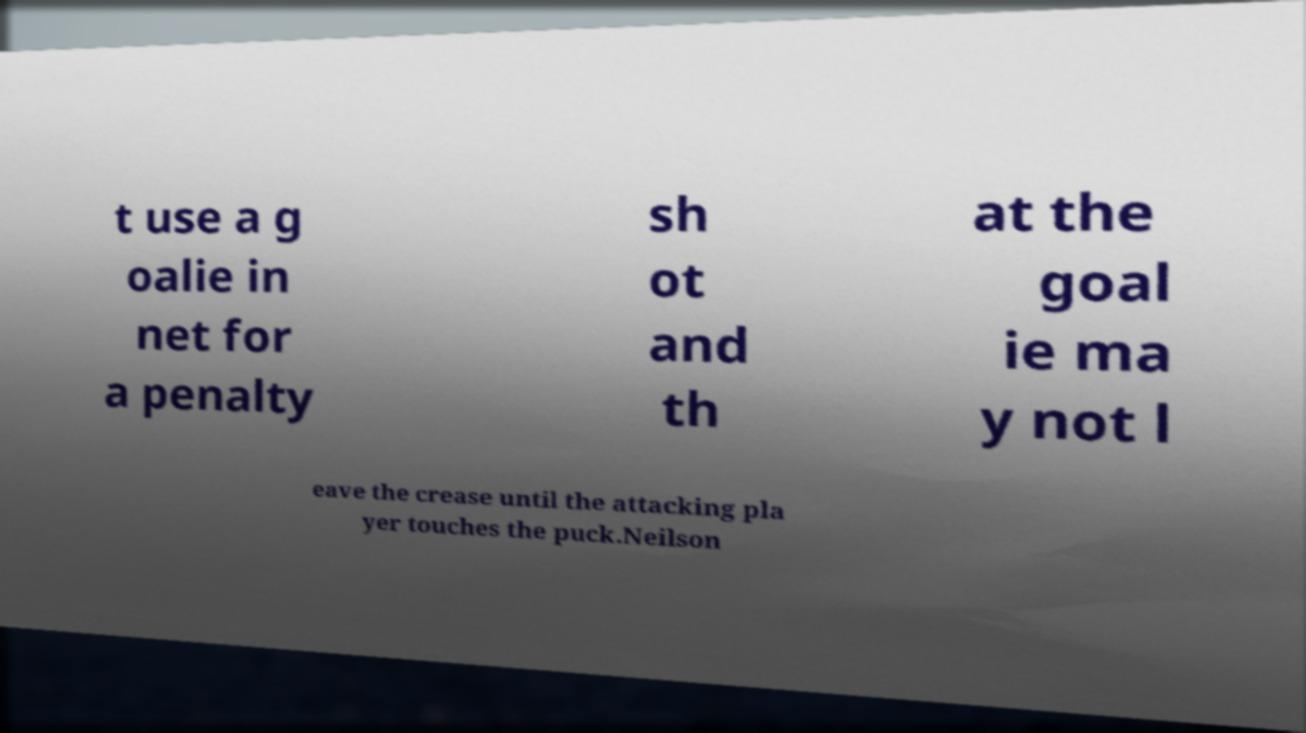Please read and relay the text visible in this image. What does it say? t use a g oalie in net for a penalty sh ot and th at the goal ie ma y not l eave the crease until the attacking pla yer touches the puck.Neilson 